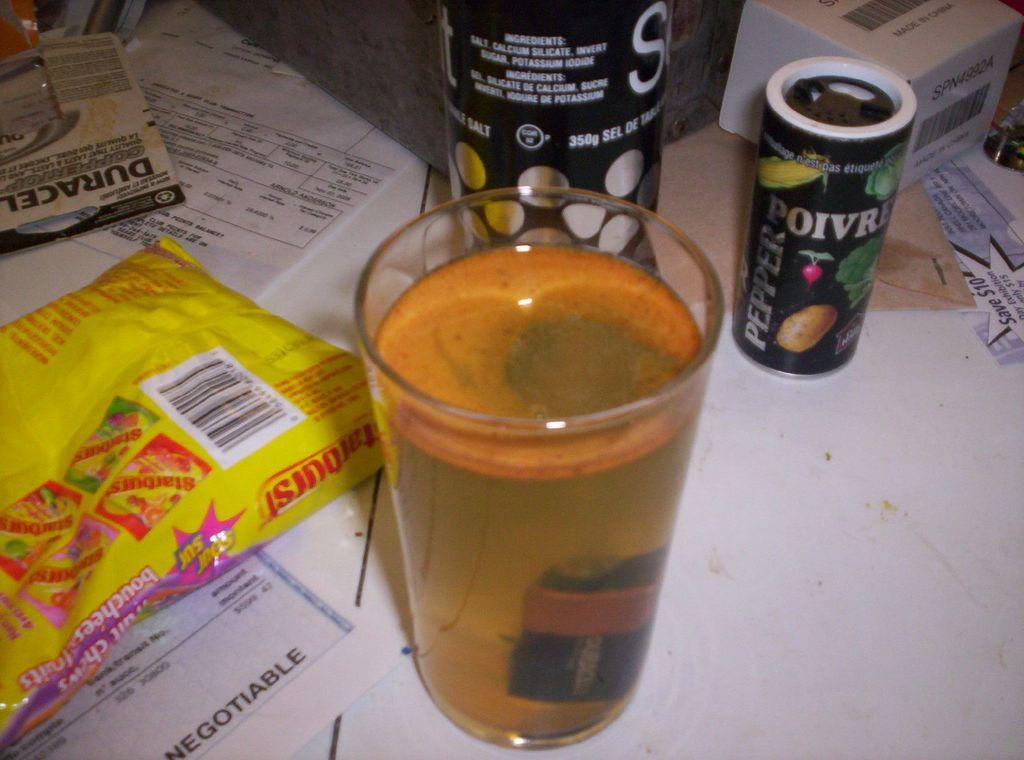<image>
Describe the image concisely. A bag of starburst lay on top of  check on a table full of other things. 